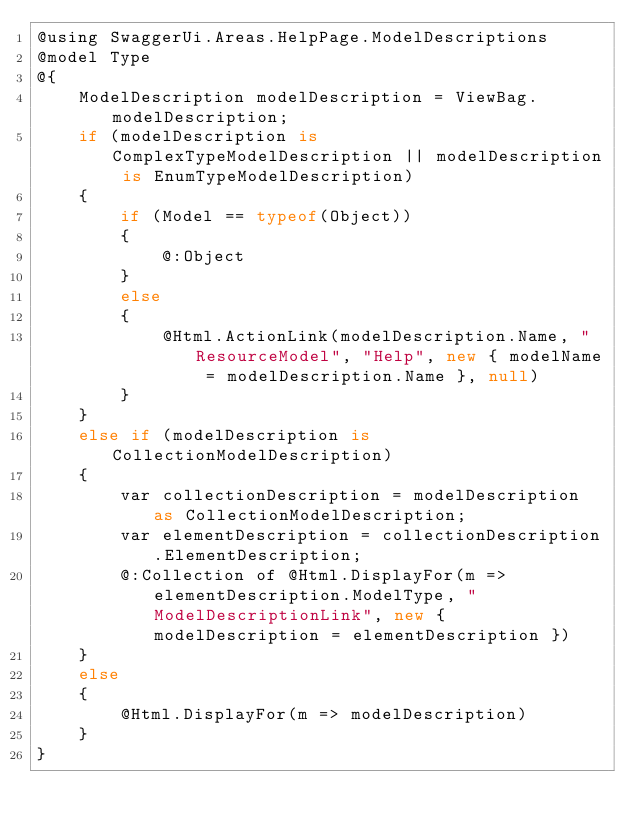Convert code to text. <code><loc_0><loc_0><loc_500><loc_500><_C#_>@using SwaggerUi.Areas.HelpPage.ModelDescriptions
@model Type
@{
    ModelDescription modelDescription = ViewBag.modelDescription;
    if (modelDescription is ComplexTypeModelDescription || modelDescription is EnumTypeModelDescription)
    {
        if (Model == typeof(Object))
        {
            @:Object
        }
        else
        {
            @Html.ActionLink(modelDescription.Name, "ResourceModel", "Help", new { modelName = modelDescription.Name }, null)
        }
    }
    else if (modelDescription is CollectionModelDescription)
    {
        var collectionDescription = modelDescription as CollectionModelDescription;
        var elementDescription = collectionDescription.ElementDescription;
        @:Collection of @Html.DisplayFor(m => elementDescription.ModelType, "ModelDescriptionLink", new { modelDescription = elementDescription })
    }
    else
    {
        @Html.DisplayFor(m => modelDescription)
    }
}</code> 